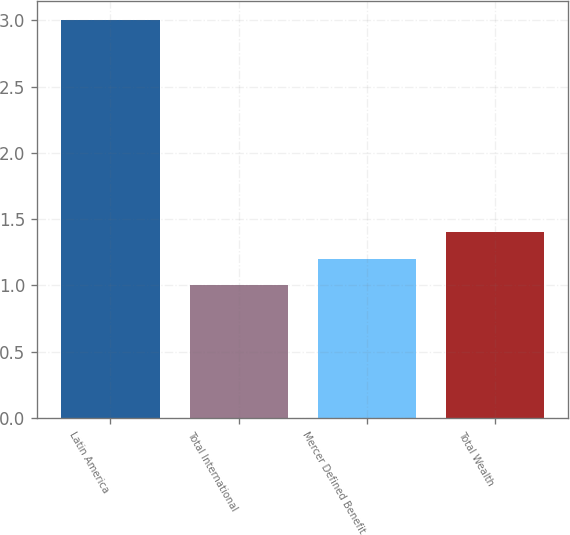Convert chart to OTSL. <chart><loc_0><loc_0><loc_500><loc_500><bar_chart><fcel>Latin America<fcel>Total International<fcel>Mercer Defined Benefit<fcel>Total Wealth<nl><fcel>3<fcel>1<fcel>1.2<fcel>1.4<nl></chart> 